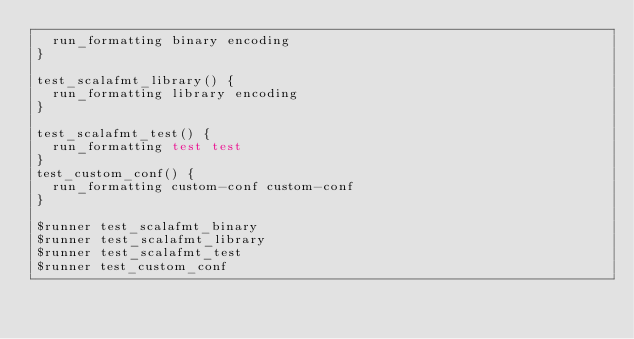<code> <loc_0><loc_0><loc_500><loc_500><_Bash_>  run_formatting binary encoding
}

test_scalafmt_library() {
  run_formatting library encoding
}

test_scalafmt_test() {
  run_formatting test test
}
test_custom_conf() {
  run_formatting custom-conf custom-conf
}

$runner test_scalafmt_binary
$runner test_scalafmt_library
$runner test_scalafmt_test
$runner test_custom_conf
</code> 